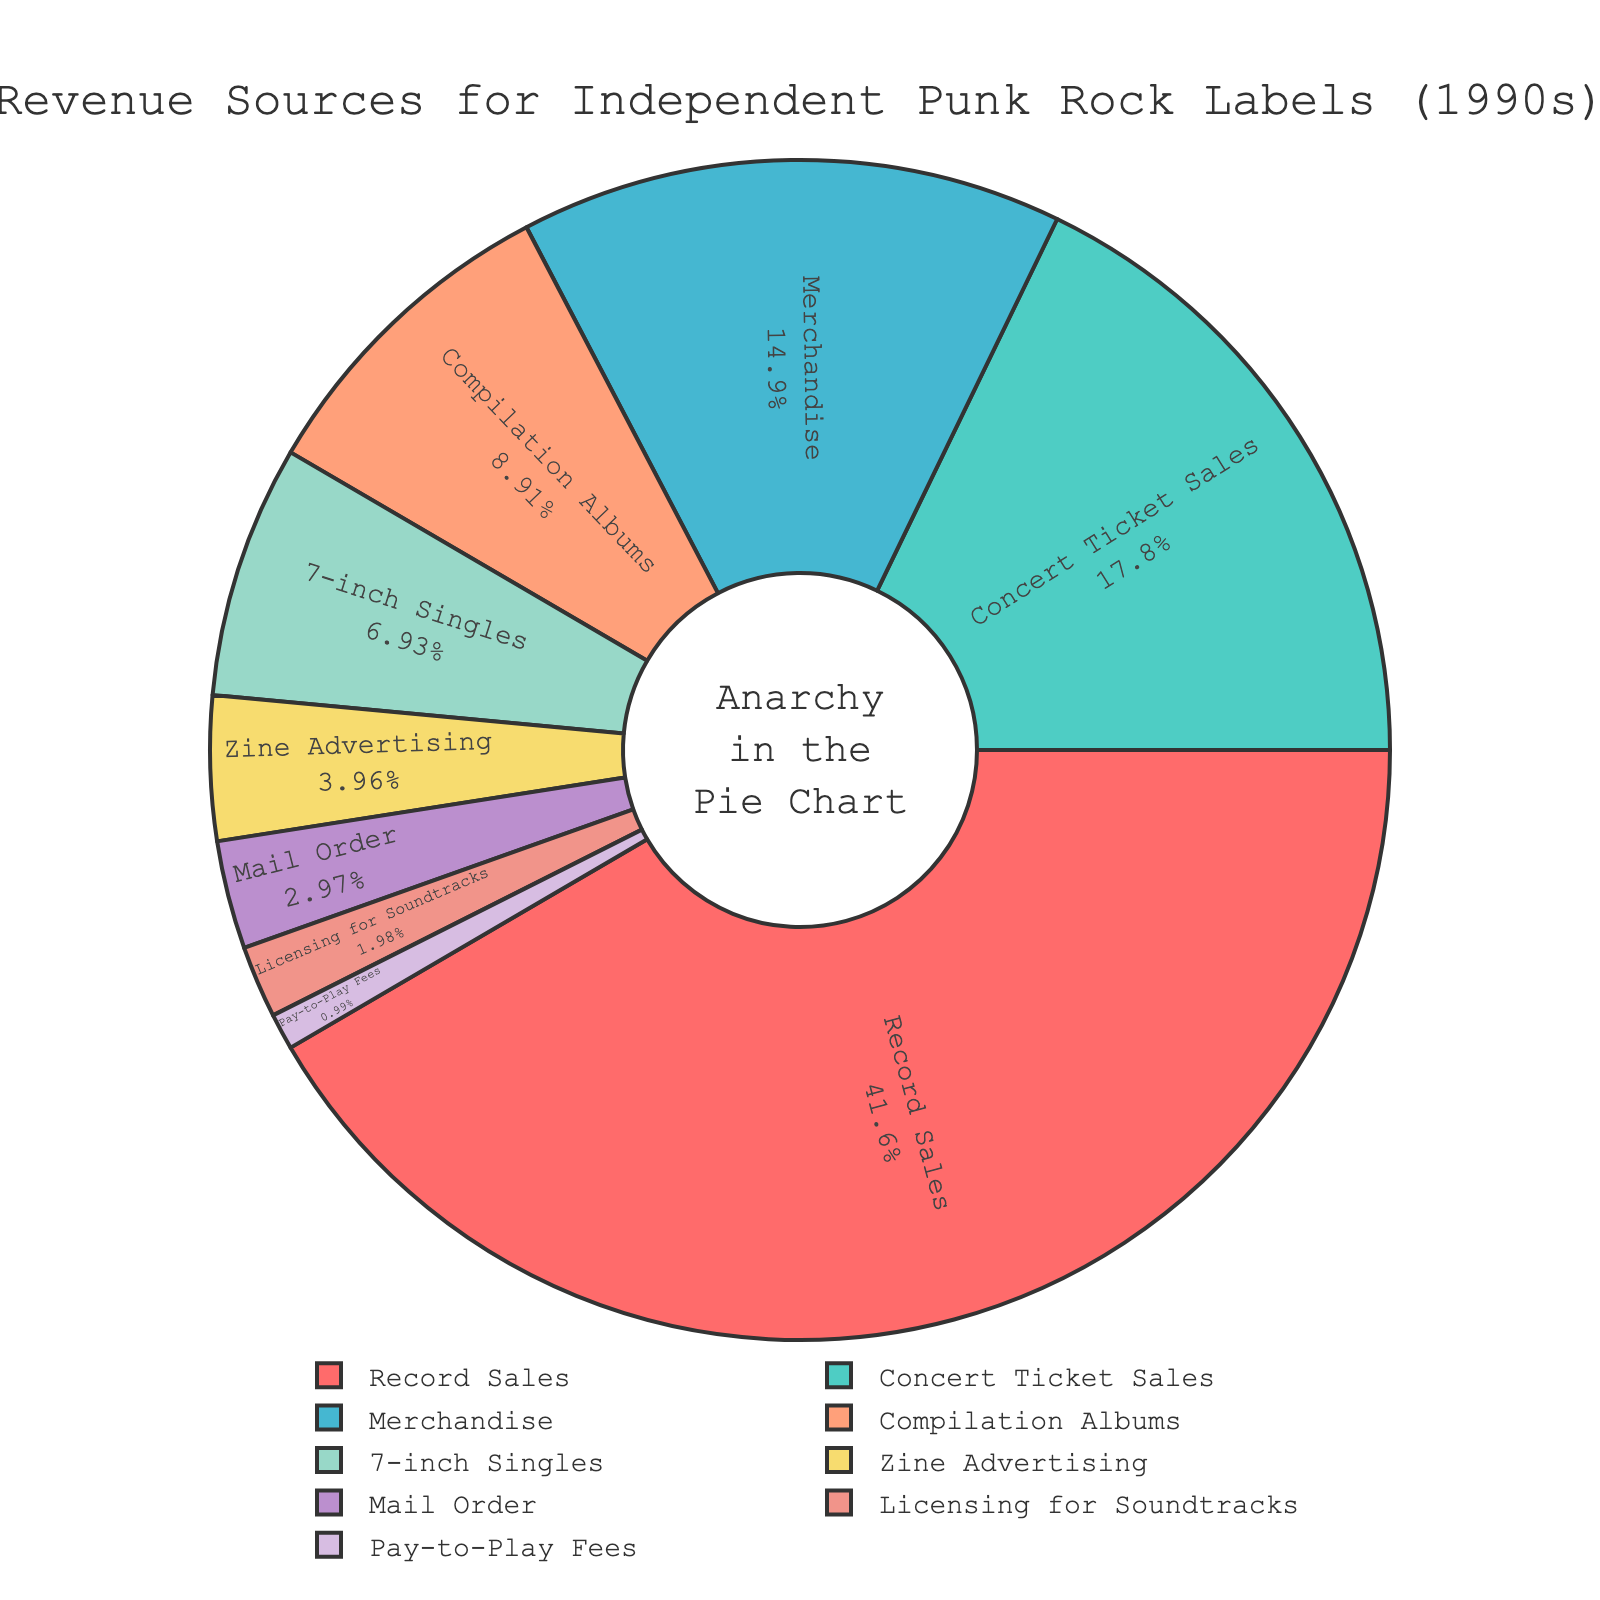which revenue source contributes the highest percentage? The highest percentage value in the pie chart is associated with Record Sales at 42%.
Answer: Record Sales What is the combined percentage of Concert Ticket Sales and Merchandise? In the pie chart, Concert Ticket Sales contribute 18% and Merchandise contributes 15%. Adding them together, we get 18% + 15% = 33%.
Answer: 33% Which revenue source contributes the least? The smallest percentage in the pie chart is associated with Pay-to-Play Fees at 1%.
Answer: Pay-to-Play Fees How does the percentage of Record Sales compare to the percentage of 7-inch Singles? Record Sales contribute 42% of revenue while 7-inch Singles contribute 7%. Therefore, Record Sales contribute 35% more than 7-inch Singles.
Answer: 35% more What's the total percentage of revenue that comes from physical media sales (Record Sales, Compilation Albums, and 7-inch Singles)? Record Sales contribute 42%, Compilation Albums contribute 9%, and 7-inch Singles contribute 7%. Adding them together, we get 42% + 9% + 7% = 58%.
Answer: 58% What percentage of revenue comes from sources other than Record Sales? To find the percentage from other sources, we subtract the percentage that comes from Record Sales (42%) from the total (100%). 100% - 42% = 58%.
Answer: 58% Which three revenue sources combined contribute the same percentage as Record Sales? The sources with percentages that add up to 42% are Concert Ticket Sales (18%), Merchandise (15%), and Compilation Albums (9%). Adding them together, we get 18% + 15% + 9% = 42%.
Answer: Concert Ticket Sales, Merchandise, Compilation Albums What are the visual indicators for Pay-to-Play Fees in the pie chart? The pie slice for Pay-to-Play Fees is visually the smallest and it is also colored distinctly among the other slices. The label for Pay-to-Play Fees is shown within the chart along with its percentage (1%).
Answer: Smallest slice, distinct color, labeled as 1% Which revenue source accounts for twice the percentage contribution of Zine Advertising? Zine Advertising contributes 4%. The source contributing twice this percentage is Merchandise, which contributes 8%. 4% * 2 = 15%.
Answer: Merchandise If Licensing for Soundtracks increased to 5%, how would that affect the overall percentage distribution? If Licensing for Soundtracks increases to 5%, the total percentage including Licensing and the initial total would be 105%. To find the new percentages, each current percentage except Licensing for Soundtracks and Pay-to-Play Fees should be proportionally decreased to make room for the increased percentage of Licensing. However, specific changes would require recalculating each individual percentage.
Answer: Requires recalculation 